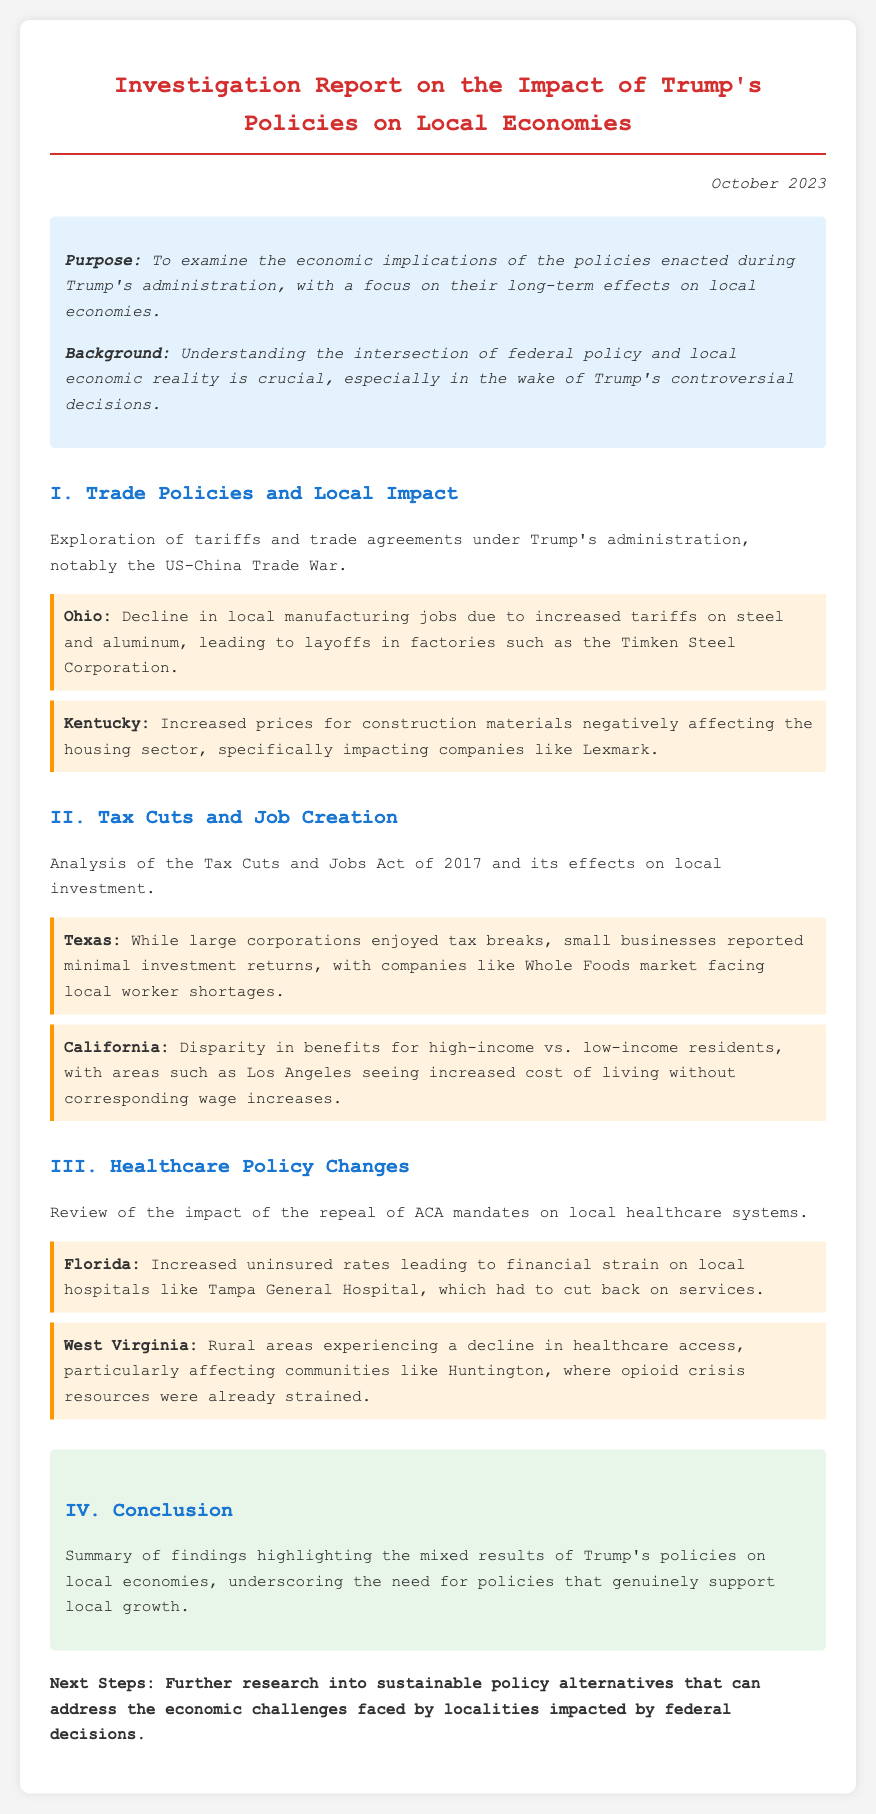What is the purpose of the report? The report aims to examine the economic implications of the policies enacted during Trump's administration.
Answer: To examine the economic implications of the policies enacted during Trump's administration What date was the report published? The date mentioned at the top of the document is when the report was published.
Answer: October 2023 Which state experienced a decline in local manufacturing jobs? This state is specifically mentioned in the case studies related to the impacts of tariffs.
Answer: Ohio What is one effect of the Tax Cuts and Jobs Act of 2017 in California? The document outlines a specific issue experienced by residents in this state related to income levels.
Answer: Increased cost of living without corresponding wage increases How did Florida's healthcare system suffer after ACA mandate repeal? This question asks for a specific consequence mentioned in the case studies examining healthcare policies.
Answer: Increased uninsured rates What major healthcare facility in Florida faced financial strain? The document identifies a specific hospital that had to reduce services due to economic challenges.
Answer: Tampa General Hospital Which policy is indicated to negatively affect small businesses in Texas? The report discusses the impacts of a particular federal tax policy on businesses in Texas.
Answer: Tax Cuts and Jobs Act of 2017 What common theme is noted in the case studies regarding Trump's policies? This question asks about the overarching conclusion drawn in the report after analyzing the case studies.
Answer: Mixed results 